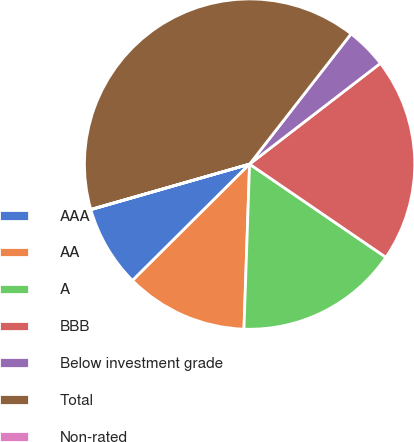Convert chart. <chart><loc_0><loc_0><loc_500><loc_500><pie_chart><fcel>AAA<fcel>AA<fcel>A<fcel>BBB<fcel>Below investment grade<fcel>Total<fcel>Non-rated<nl><fcel>8.01%<fcel>12.0%<fcel>16.0%<fcel>19.99%<fcel>4.02%<fcel>39.96%<fcel>0.02%<nl></chart> 